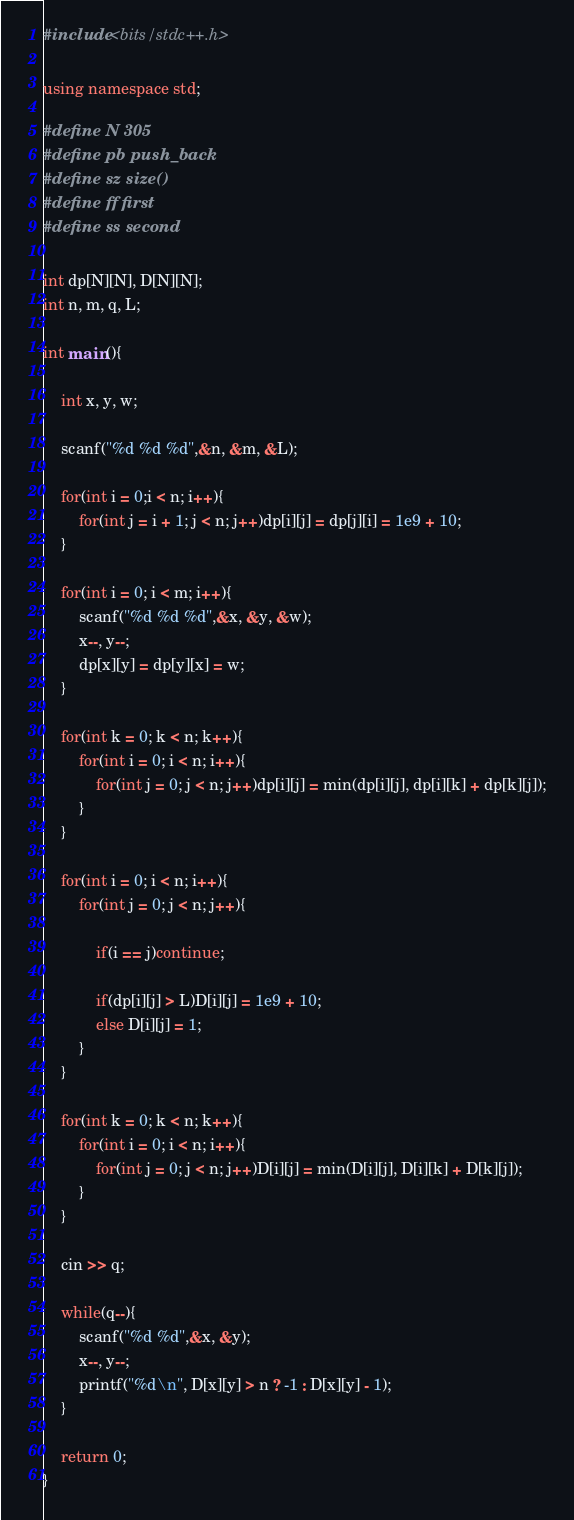<code> <loc_0><loc_0><loc_500><loc_500><_C++_>#include <bits/stdc++.h>

using namespace std;

#define N 305
#define pb push_back
#define sz size()
#define ff first
#define ss second

int dp[N][N], D[N][N];
int n, m, q, L;

int main(){

    int x, y, w;

    scanf("%d %d %d",&n, &m, &L);

    for(int i = 0;i < n; i++){
        for(int j = i + 1; j < n; j++)dp[i][j] = dp[j][i] = 1e9 + 10;
    }

    for(int i = 0; i < m; i++){
        scanf("%d %d %d",&x, &y, &w);
        x--, y--;
        dp[x][y] = dp[y][x] = w;
    }

    for(int k = 0; k < n; k++){
        for(int i = 0; i < n; i++){
            for(int j = 0; j < n; j++)dp[i][j] = min(dp[i][j], dp[i][k] + dp[k][j]);
        }
    }

    for(int i = 0; i < n; i++){
        for(int j = 0; j < n; j++){

            if(i == j)continue;

            if(dp[i][j] > L)D[i][j] = 1e9 + 10;
            else D[i][j] = 1;
        }
    }

    for(int k = 0; k < n; k++){
        for(int i = 0; i < n; i++){
            for(int j = 0; j < n; j++)D[i][j] = min(D[i][j], D[i][k] + D[k][j]);
        }
    }
    
    cin >> q;
    
    while(q--){
        scanf("%d %d",&x, &y);
        x--, y--;
        printf("%d\n", D[x][y] > n ? -1 : D[x][y] - 1);
    }

    return 0;
}</code> 